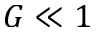<formula> <loc_0><loc_0><loc_500><loc_500>G \ll 1</formula> 